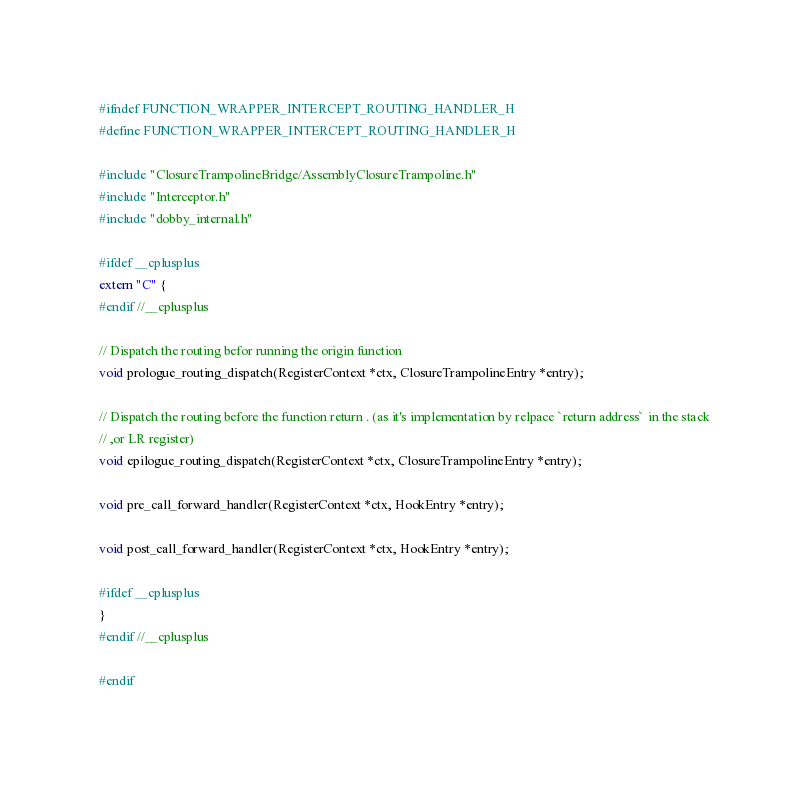<code> <loc_0><loc_0><loc_500><loc_500><_C_>#ifndef FUNCTION_WRAPPER_INTERCEPT_ROUTING_HANDLER_H
#define FUNCTION_WRAPPER_INTERCEPT_ROUTING_HANDLER_H

#include "ClosureTrampolineBridge/AssemblyClosureTrampoline.h"
#include "Interceptor.h"
#include "dobby_internal.h"

#ifdef __cplusplus
extern "C" {
#endif //__cplusplus

// Dispatch the routing befor running the origin function
void prologue_routing_dispatch(RegisterContext *ctx, ClosureTrampolineEntry *entry);

// Dispatch the routing before the function return . (as it's implementation by relpace `return address` in the stack
// ,or LR register)
void epilogue_routing_dispatch(RegisterContext *ctx, ClosureTrampolineEntry *entry);

void pre_call_forward_handler(RegisterContext *ctx, HookEntry *entry);

void post_call_forward_handler(RegisterContext *ctx, HookEntry *entry);

#ifdef __cplusplus
}
#endif //__cplusplus

#endif</code> 